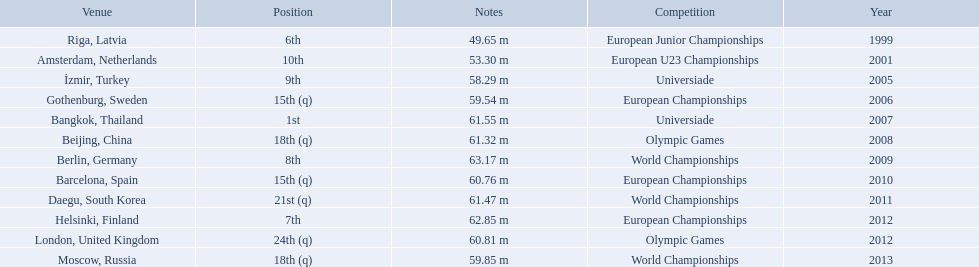Which competitions has gerhard mayer competed in since 1999? European Junior Championships, European U23 Championships, Universiade, European Championships, Universiade, Olympic Games, World Championships, European Championships, World Championships, European Championships, Olympic Games, World Championships. Of these competition, in which ones did he throw at least 60 m? Universiade, Olympic Games, World Championships, European Championships, World Championships, European Championships, Olympic Games. Of these throws, which was his longest? 63.17 m. 